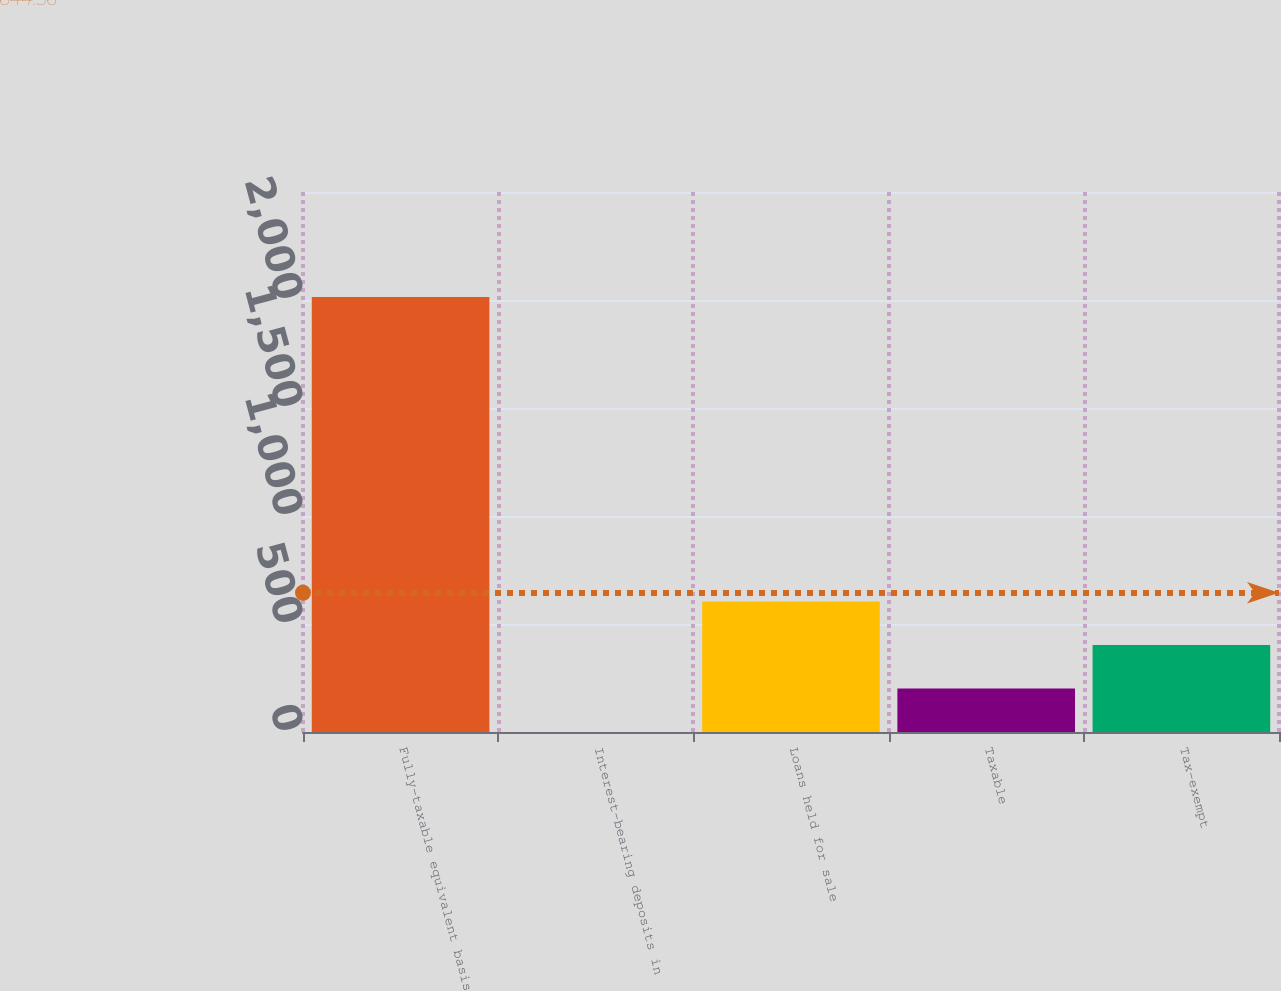<chart> <loc_0><loc_0><loc_500><loc_500><bar_chart><fcel>Fully-taxable equivalent basis<fcel>Interest-bearing deposits in<fcel>Loans held for sale<fcel>Taxable<fcel>Tax-exempt<nl><fcel>2014<fcel>0.12<fcel>604.29<fcel>201.51<fcel>402.9<nl></chart> 